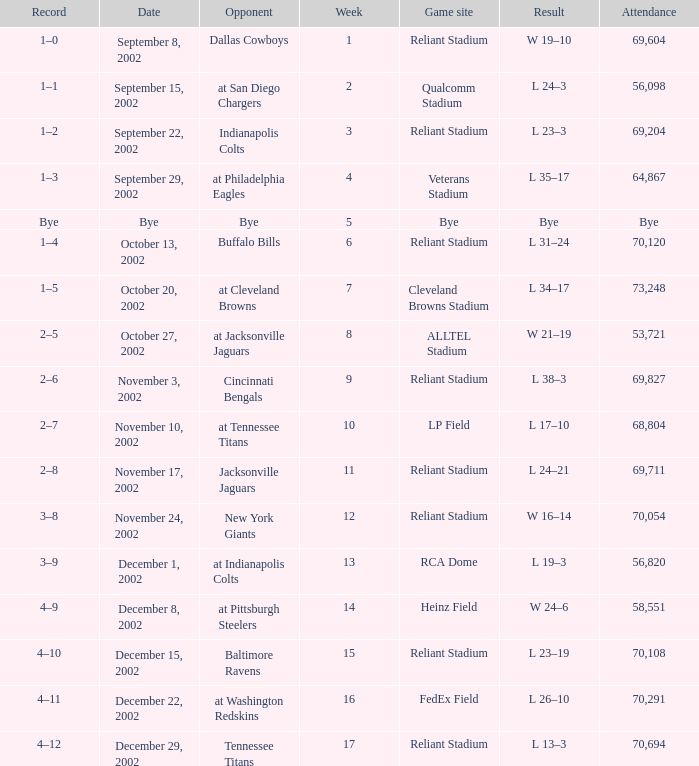What is the earliest week that the Texans played at the Cleveland Browns Stadium? 7.0. 